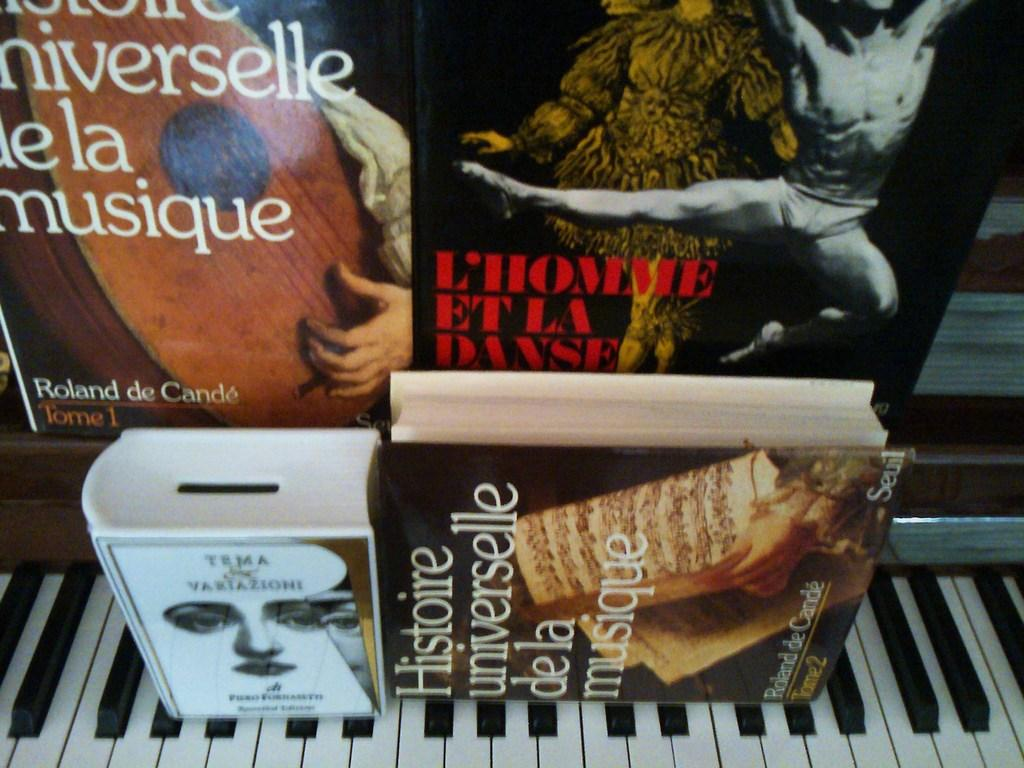What musical instrument is present in the image? There is a piano in the image. What other objects can be seen in the image? There is a box, a book, and posters in the image. What is depicted on the posters? The posters have pictures of a person on them and text written on them. How many pages of the potato can be seen in the image? There is no potato present in the image, so it is not possible to determine the number of pages. 